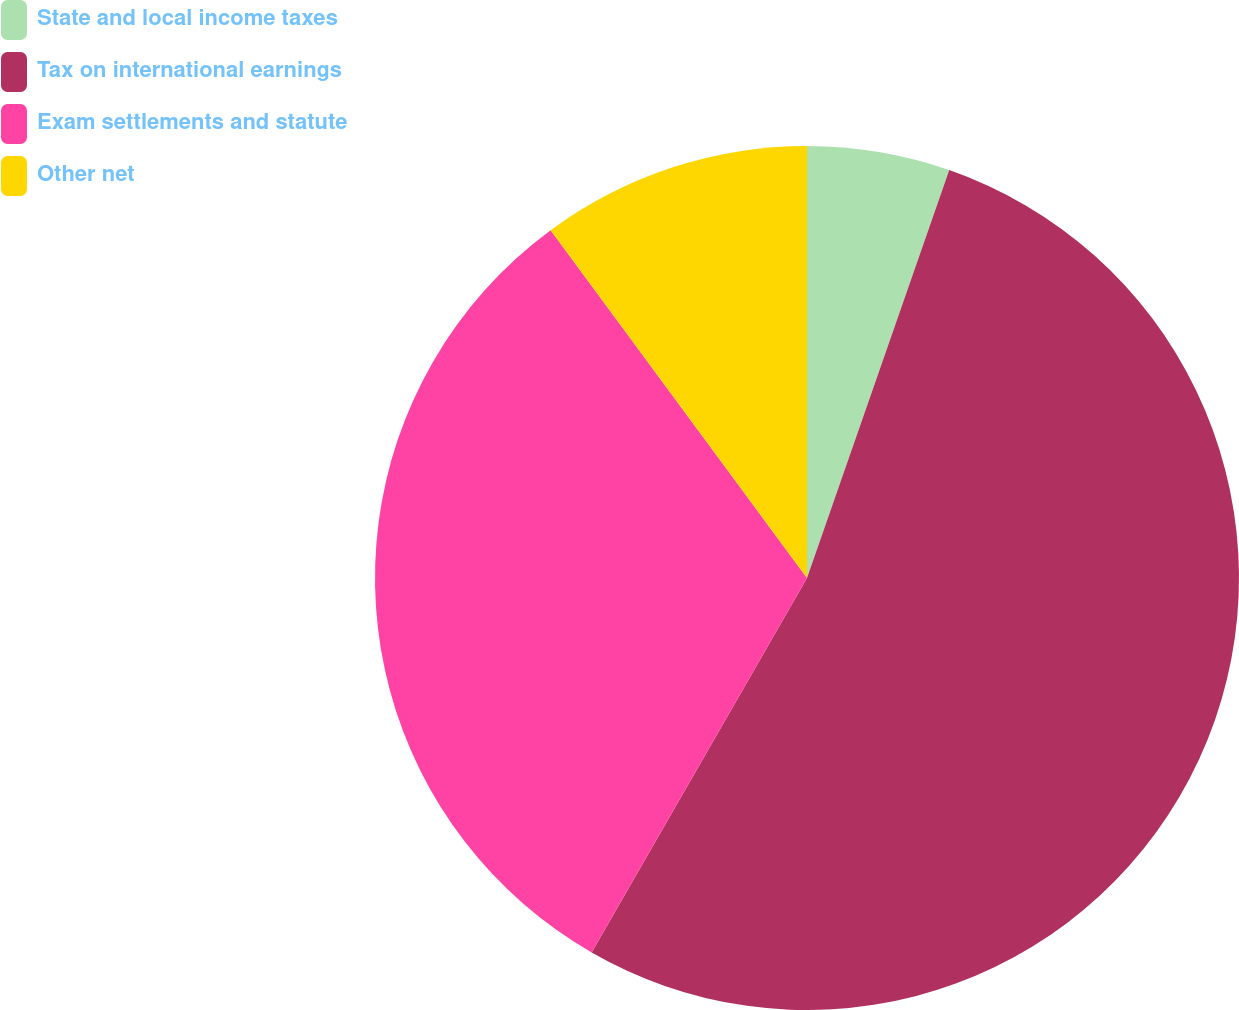<chart> <loc_0><loc_0><loc_500><loc_500><pie_chart><fcel>State and local income taxes<fcel>Tax on international earnings<fcel>Exam settlements and statute<fcel>Other net<nl><fcel>5.34%<fcel>52.96%<fcel>31.58%<fcel>10.11%<nl></chart> 